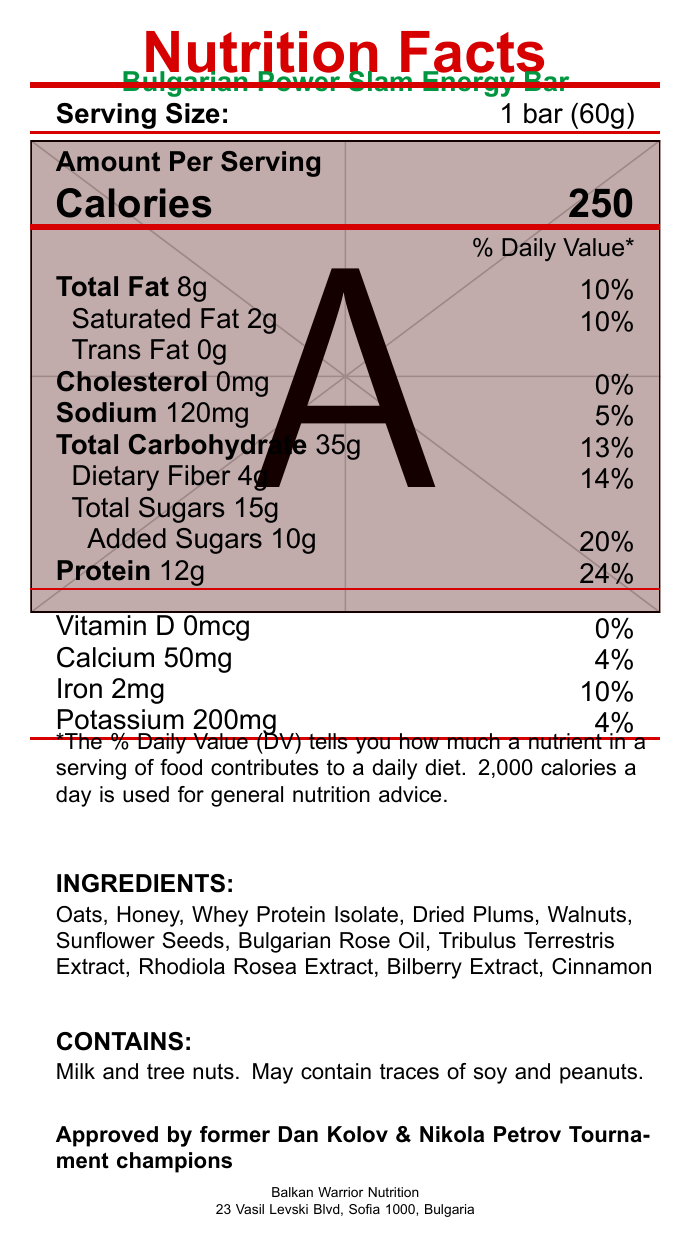what is the serving size of the Bulgarian Power Slam Energy Bar? The serving size is clearly mentioned as "1 bar (60g)" in the document.
Answer: 1 bar (60g) how many calories are in one serving of the energy bar? The document specifies 250 calories per serving, which is "1 bar (60g)."
Answer: 250 calories what is the total fat content in one serving? The document lists "Total Fat" as 8g per serving.
Answer: 8g what percentage of the daily recommended value of protein does one serving provide? The document states that the "Protein" content is 12g, which is 24% of the daily recommended value.
Answer: 24% name three Bulgarian herbs included in the ingredients. The ingredients list includes Bulgarian Rose Oil, Tribulus Terrestris Extract, and Rhodiola Rosea Extract.
Answer: Bulgarian Rose Oil, Tribulus Terrestris Extract, Rhodiola Rosea Extract which special feature is related to promoting testosterone support? A. Contains Bulgarian Rose Oil B. Enhanced with Bilberry Extract C. Contains Tribulus Terrestris D. Good Source of Fiber The document states that "Contains Tribulus Terrestris for natural testosterone support."
Answer: C what is the daily value percentage of added sugars in the energy bar? A. 10% B. 20% C. 30% D. 5% The daily value for added sugars is listed as 20%, which corresponds to option B.
Answer: B does the energy bar contain any trans fat? The document clearly states that the trans fat content is "0g".
Answer: No does the energy bar contain any artificial preservatives? According to the claim statements, the energy bar has "No artificial preservatives."
Answer: No summarize the main features of the Bulgarian Power Slam Energy Bar. This summary consolidates the main nutritional information, ingredients, special features, and claims of the energy bar.
Answer: The Bulgarian Power Slam Energy Bar is a high-protein (24%), fiber-rich (14%) bar with 250 calories per serving. It contains Bulgarian herbs such as Bulgarian Rose Oil, Tribulus Terrestris, and Rhodiola Rosea. Approved by former Dan Kolov & Nikola Petrov Tournament champions, it is free of artificial preservatives and includes ingredients like oats, honey, whey protein isolate, and dried plums. It also has allergen alerts for milk and tree nuts. what is the amount of cholesterol in one serving of the energy bar? The document lists "Cholesterol" as "0mg" per serving, indicating there is no cholesterol in the bar.
Answer: 0mg which company manufactures the Bulgarian Power Slam Energy Bar? The document mentions that the manufacturer is "Balkan Warrior Nutrition" based in Sofia, Bulgaria.
Answer: Balkan Warrior Nutrition how much sodium is in one serving of the energy bar? The sodium content per serving is clearly stated as 120mg.
Answer: 120mg identify two main benefits of Rhodiola Rosea extract in the energy bar. The document states that Rhodiola Rosea is added for increased endurance and recovery.
Answer: Increased endurance and recovery what is the expiry period after opening the energy bar? The storage instructions note that the energy bar should be consumed within 3 days of opening.
Answer: 3 days what flavorings or extracts are added to the energy bar? A. Vanilla Extract B. Almond Extract C. Cinnamon and Bilberry Extract D. Coconut Oil According to the ingredient list, Cinnamon and Bilberry Extract are included in the energy bar.
Answer: C is there information on the bar's effect on blood sugar levels? The document does not provide any details regarding the energy bar's effect on blood sugar levels or glycemic index.
Answer: Not enough information where should the energy bar be stored? The document advises storing the energy bar in a cool, dry place.
Answer: In a cool, dry place 